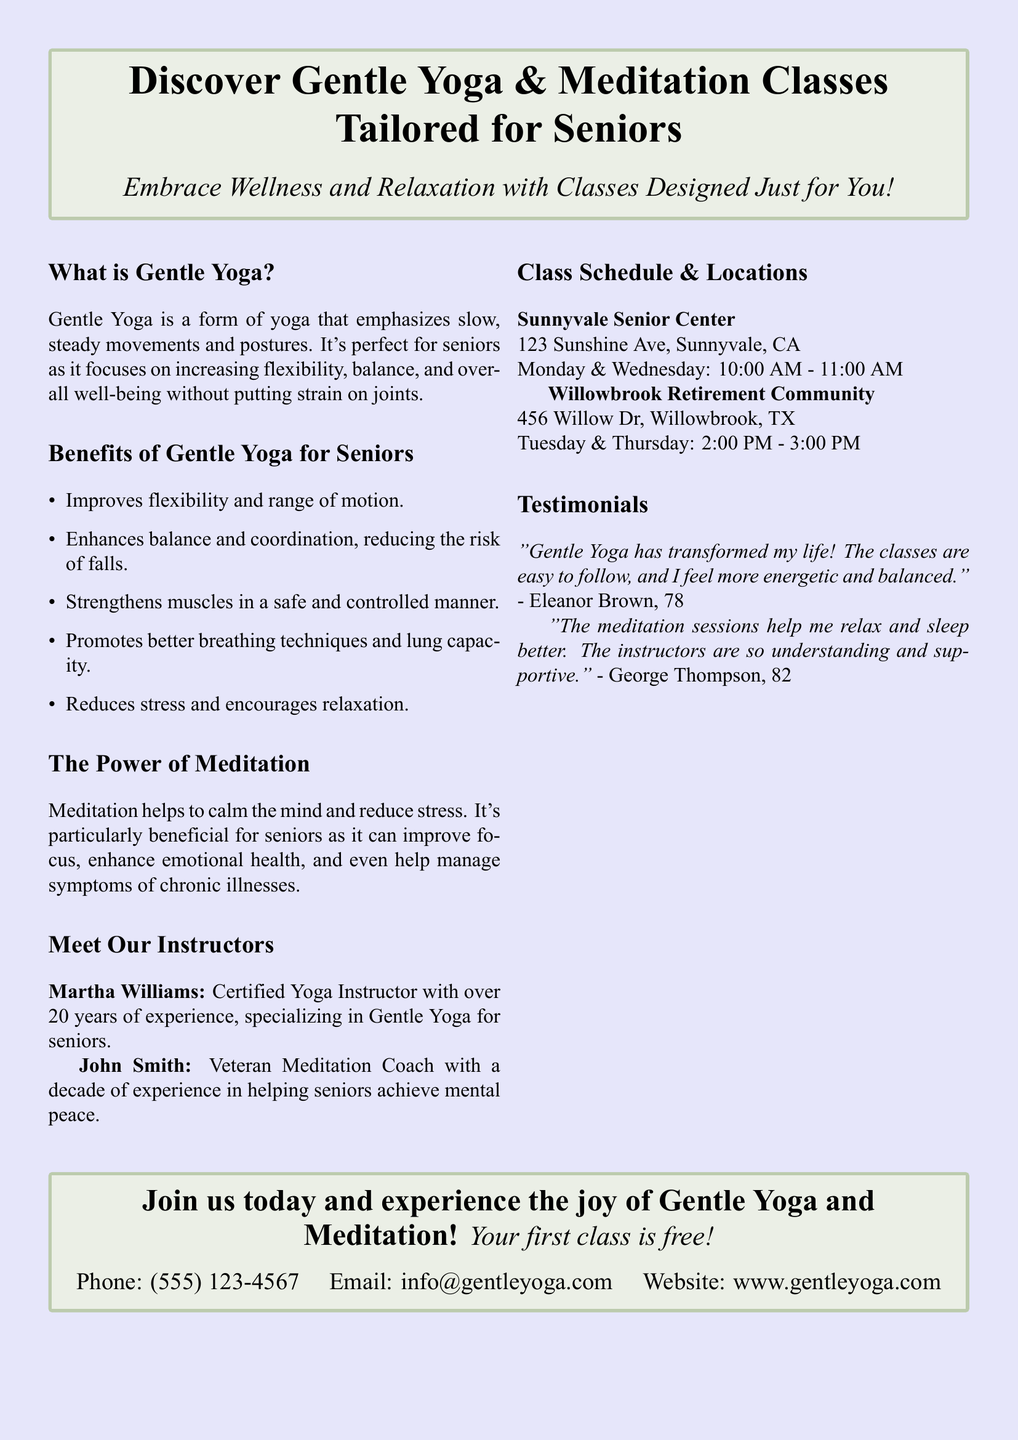What is Gentle Yoga? Gentle Yoga is a form of yoga that emphasizes slow, steady movements and postures, perfect for seniors.
Answer: A form of yoga What are the benefits of Gentle Yoga for seniors? The document lists several benefits including improved flexibility and reduced stress.
Answer: Improved flexibility What days are classes held at the Sunnyvale Senior Center? The document specifies which days classes occur at each location, Sunnyvale has Monday and Wednesday.
Answer: Monday and Wednesday Who is the certified yoga instructor mentioned? The advertisement names instructors, including Martha Williams as a certified Yoga Instructor.
Answer: Martha Williams What is the first class offer? The advertisement mentions an incentive for new participants to try the classes.
Answer: First class is free What are the timing for the classes at Willowbrook Retirement Community? The document provides specific timing for the classes at this center, which is noted in the schedule.
Answer: 2:00 PM - 3:00 PM Who is a veteran meditation coach? The advertisement introduces John Smith as a meditation coach with specific experience.
Answer: John Smith What is the contact number provided for the classes? Contact information including a phone number is listed in the advertisement for inquiries.
Answer: (555) 123-4567 What is the main purpose of this document? The document is designed to promote a specific wellness activity tailored for a demographic.
Answer: Promote relaxation and wellness 